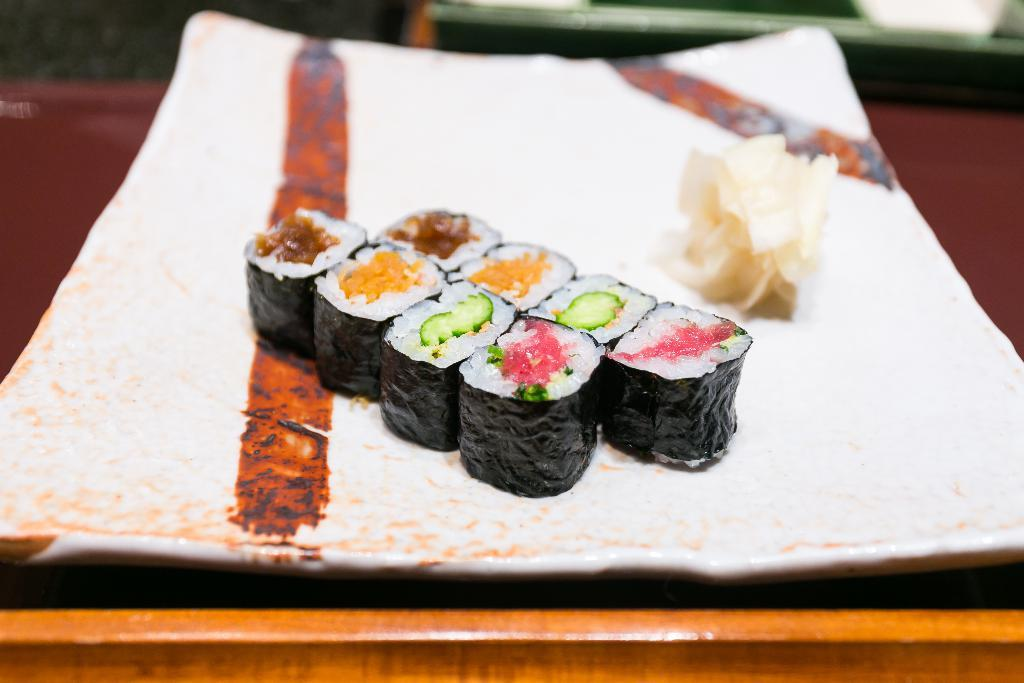What is on the plate in the image? There are food items on a plate in the image. What is the food placed on? The food items are placed on an object. Can you describe the background of the image? The background of the image is blurred. What type of pain can be seen on the rat's face in the image? There is no rat present in the image, and therefore no pain can be observed on its face. 